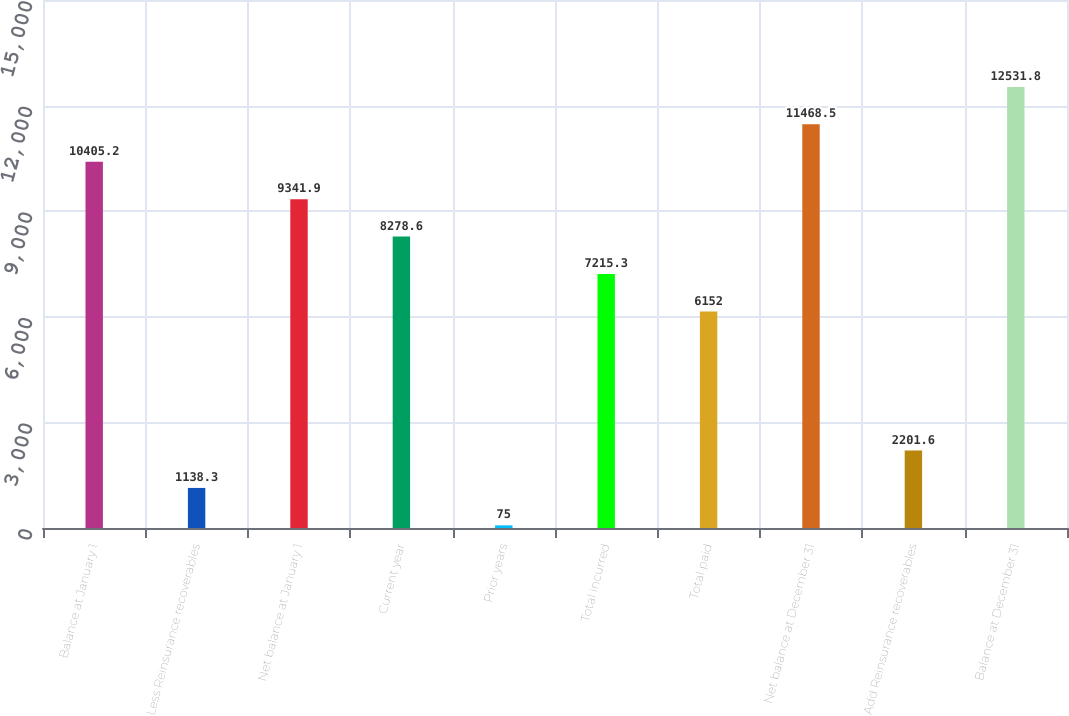Convert chart to OTSL. <chart><loc_0><loc_0><loc_500><loc_500><bar_chart><fcel>Balance at January 1<fcel>Less Reinsurance recoverables<fcel>Net balance at January 1<fcel>Current year<fcel>Prior years<fcel>Total incurred<fcel>Total paid<fcel>Net balance at December 31<fcel>Add Reinsurance recoverables<fcel>Balance at December 31<nl><fcel>10405.2<fcel>1138.3<fcel>9341.9<fcel>8278.6<fcel>75<fcel>7215.3<fcel>6152<fcel>11468.5<fcel>2201.6<fcel>12531.8<nl></chart> 